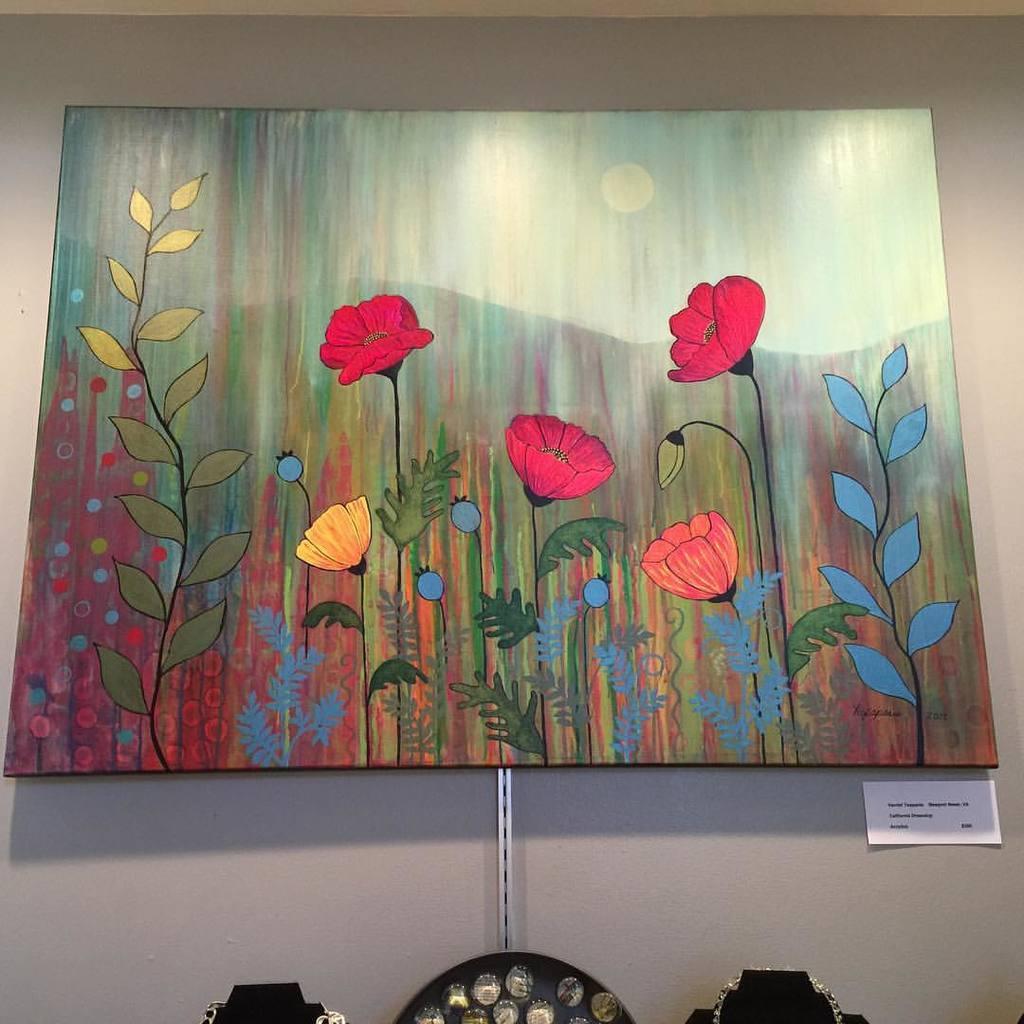Can you describe this image briefly? In this picture we can see a frame, paper on the wall and some objects and on this frame we can see flowers, leaves, mountains, sky. 